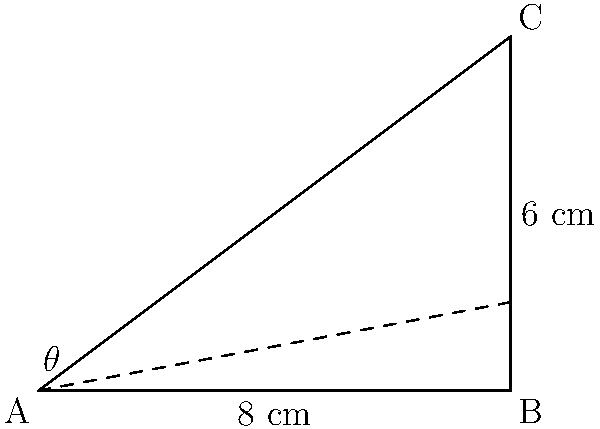In a classic car's suspension system, the control arm forms a right triangle with the chassis. If the control arm is 8 cm long and its mounting point is 6 cm higher than its connection to the wheel, what is the angle $\theta$ between the control arm and the chassis? To solve this problem, we'll use trigonometry, specifically the inverse tangent function (arctan or $\tan^{-1}$).

1. Identify the triangle:
   - The control arm forms the base (adjacent side) of the triangle, which is 8 cm long.
   - The height difference forms the opposite side, which is 6 cm long.
   - We need to find the angle $\theta$ between the control arm and the chassis.

2. Choose the appropriate trigonometric function:
   - We have the opposite and adjacent sides, so we'll use tangent.
   - $\tan(\theta) = \frac{\text{opposite}}{\text{adjacent}}$

3. Set up the equation:
   $\tan(\theta) = \frac{6}{8}$

4. Solve for $\theta$ using the inverse tangent function:
   $\theta = \tan^{-1}(\frac{6}{8})$

5. Calculate the result:
   $\theta = \tan^{-1}(0.75) \approx 36.87°$

6. Round to the nearest degree:
   $\theta \approx 37°$
Answer: $37°$ 